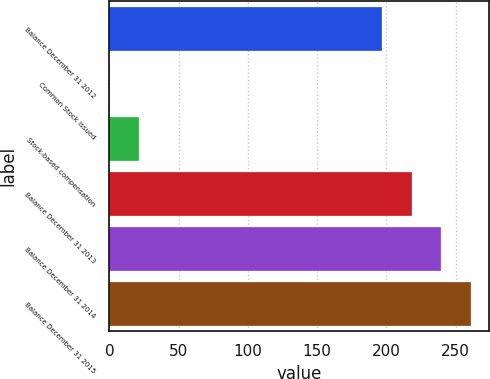Convert chart. <chart><loc_0><loc_0><loc_500><loc_500><bar_chart><fcel>Balance December 31 2012<fcel>Common Stock issued<fcel>Stock-based compensation<fcel>Balance December 31 2013<fcel>Balance December 31 2014<fcel>Balance December 31 2015<nl><fcel>197.1<fcel>0.13<fcel>21.42<fcel>218.39<fcel>239.68<fcel>260.97<nl></chart> 